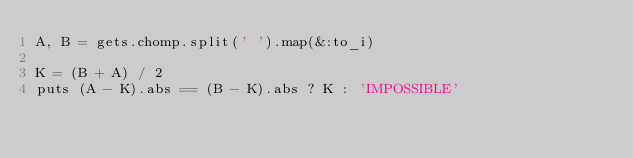Convert code to text. <code><loc_0><loc_0><loc_500><loc_500><_Ruby_>A, B = gets.chomp.split(' ').map(&:to_i)

K = (B + A) / 2
puts (A - K).abs == (B - K).abs ? K : 'IMPOSSIBLE'
</code> 